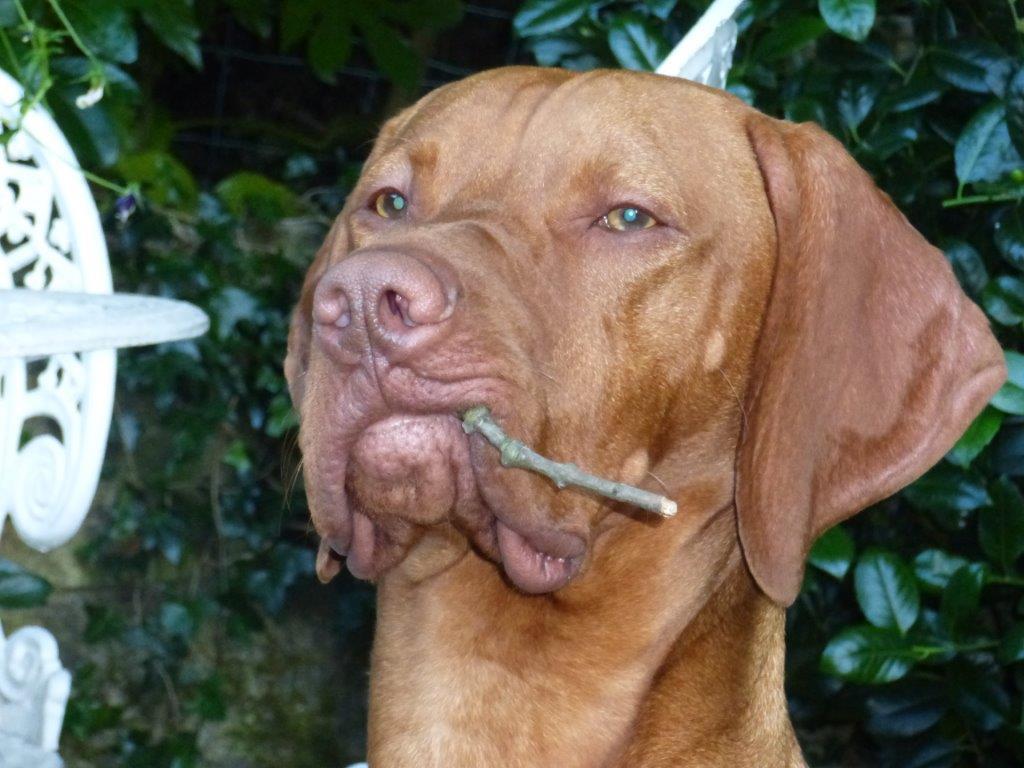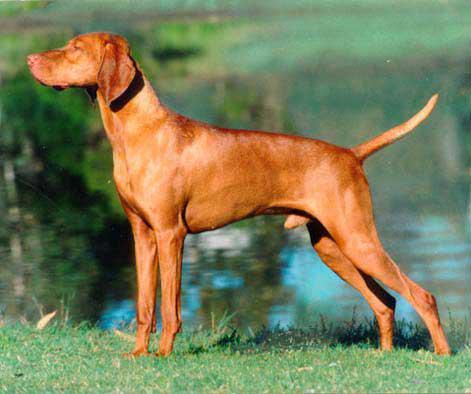The first image is the image on the left, the second image is the image on the right. Analyze the images presented: Is the assertion "A dog is holding something in its mouth." valid? Answer yes or no. Yes. The first image is the image on the left, the second image is the image on the right. Considering the images on both sides, is "The dog on the left has something held in its mouth, and the dog on the right is standing on green grass with its tail extended." valid? Answer yes or no. Yes. 